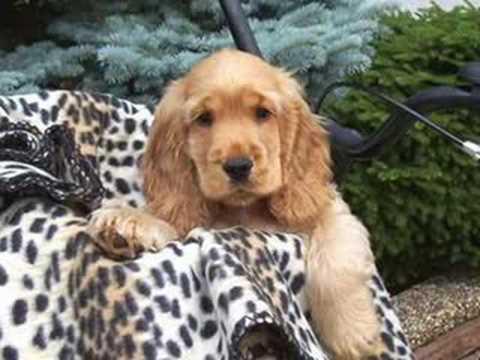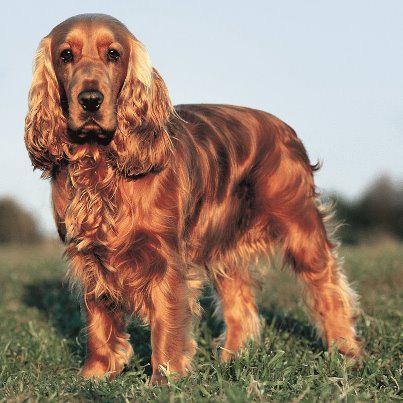The first image is the image on the left, the second image is the image on the right. Examine the images to the left and right. Is the description "An image shows a gold-colored puppy with at least one paw draped over something." accurate? Answer yes or no. Yes. The first image is the image on the left, the second image is the image on the right. Assess this claim about the two images: "One of the images contains a dog only showing its two front legs.". Correct or not? Answer yes or no. Yes. 